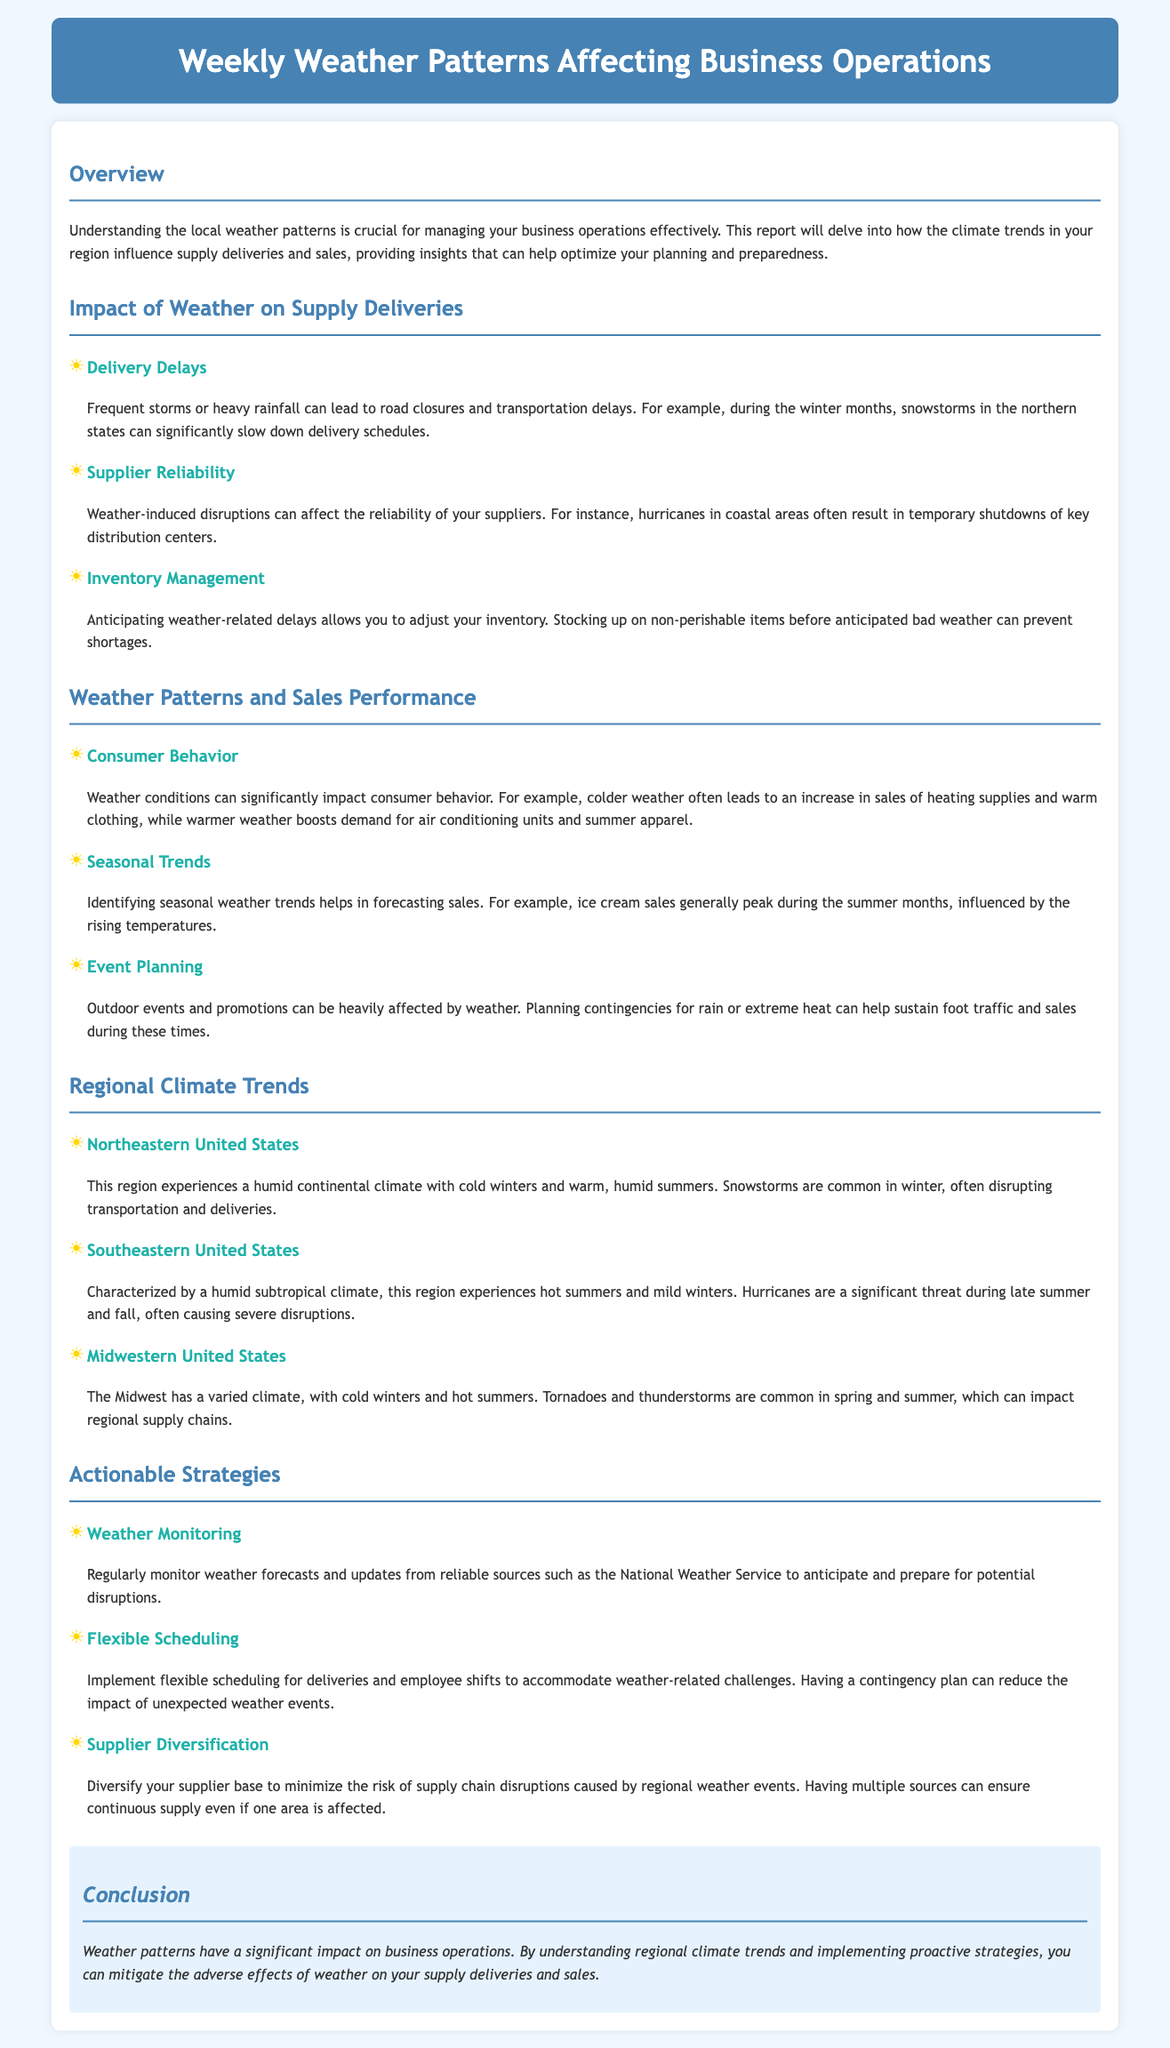What is the main purpose of the report? The report aims to understand how local weather patterns influence business operations, particularly supply deliveries and sales.
Answer: Understanding local weather patterns What are the common weather conditions mentioned for the Northeastern United States? The document states that the Northeastern U.S. experiences a humid continental climate with cold winters and warm, humid summers.
Answer: Humid continental climate What happens to sales of heating supplies during colder weather? The report indicates that colder weather often leads to an increase in sales of heating supplies and warm clothing.
Answer: Increase in sales What should businesses do before anticipated bad weather? It suggests that businesses should stock up on non-perishable items to prevent shortages.
Answer: Stock up on non-perishable items Which strategy involves monitoring updates from reliable sources? Regularly monitoring weather forecasts is part of the proactive strategy for anticipating potential disruptions.
Answer: Weather monitoring How often do snowstorms occur in the Northeastern states? The document mentions that snowstorms are common in winter.
Answer: Common in winter Which factor is a significant threat during late summer and fall in the Southeastern U.S.? The document notes that hurricanes pose a significant threat during this period.
Answer: Hurricanes What is a key recommendation for minimizing supply chain disruptions? The report advises diversifying the supplier base to minimize risks caused by regional weather events.
Answer: Supplier diversification What type of climate does the Southeastern United States experience? It is characterized by a humid subtropical climate.
Answer: Humid subtropical climate 